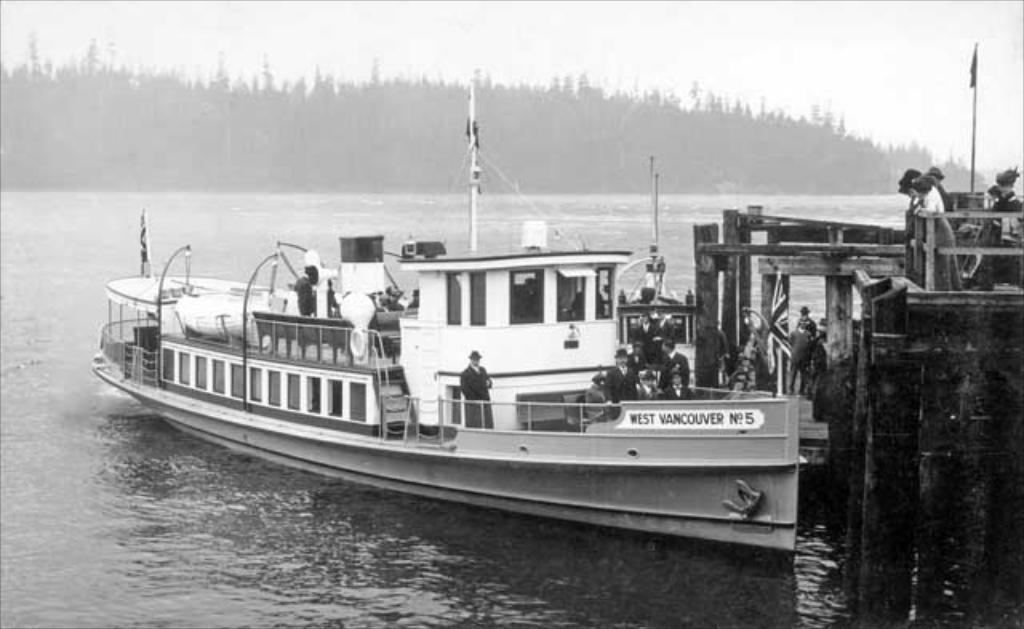What is the name of this boat?
Your answer should be compact. West vancouver no 5. What is the number of the boat?
Make the answer very short. 5. 